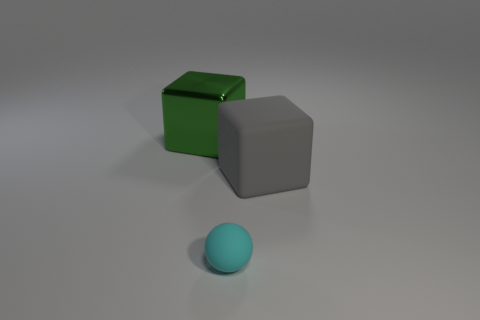Is there any other thing that has the same size as the cyan rubber ball?
Ensure brevity in your answer.  No. What size is the other object that is the same shape as the gray object?
Provide a succinct answer. Large. Are the cube to the left of the cyan thing and the small cyan thing made of the same material?
Offer a terse response. No. Is the shape of the big matte object the same as the small rubber thing?
Provide a short and direct response. No. What number of objects are objects that are behind the tiny cyan matte object or tiny rubber things?
Make the answer very short. 3. The gray cube that is made of the same material as the small cyan ball is what size?
Your answer should be very brief. Large. How many cubes are the same color as the tiny rubber object?
Make the answer very short. 0. How many large objects are either shiny things or cyan rubber objects?
Provide a short and direct response. 1. Is there a tiny blue block made of the same material as the large green cube?
Keep it short and to the point. No. What material is the large thing in front of the metallic block?
Your answer should be compact. Rubber. 